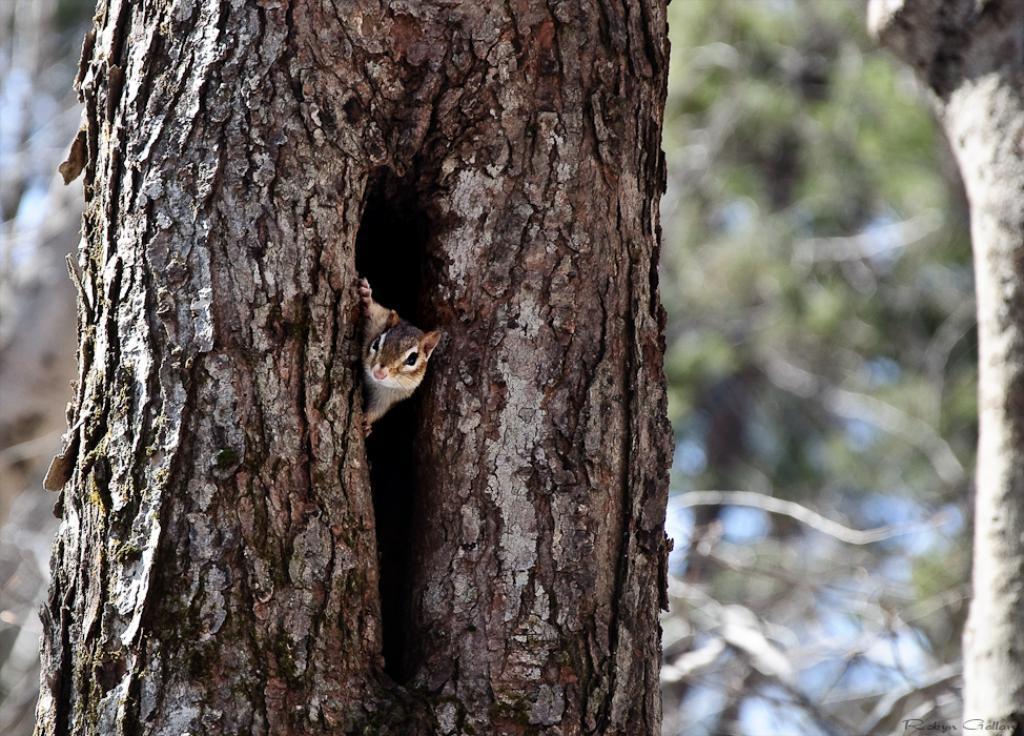In one or two sentences, can you explain what this image depicts? In this picture we can see a squirrel in the tree trunk and behind the tree trunk there is the blurred background. 